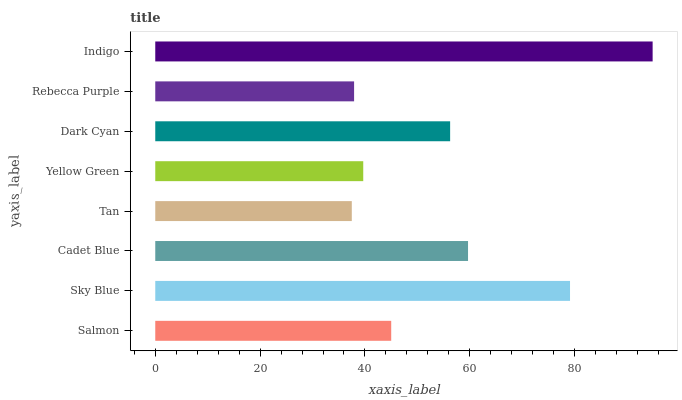Is Tan the minimum?
Answer yes or no. Yes. Is Indigo the maximum?
Answer yes or no. Yes. Is Sky Blue the minimum?
Answer yes or no. No. Is Sky Blue the maximum?
Answer yes or no. No. Is Sky Blue greater than Salmon?
Answer yes or no. Yes. Is Salmon less than Sky Blue?
Answer yes or no. Yes. Is Salmon greater than Sky Blue?
Answer yes or no. No. Is Sky Blue less than Salmon?
Answer yes or no. No. Is Dark Cyan the high median?
Answer yes or no. Yes. Is Salmon the low median?
Answer yes or no. Yes. Is Cadet Blue the high median?
Answer yes or no. No. Is Sky Blue the low median?
Answer yes or no. No. 